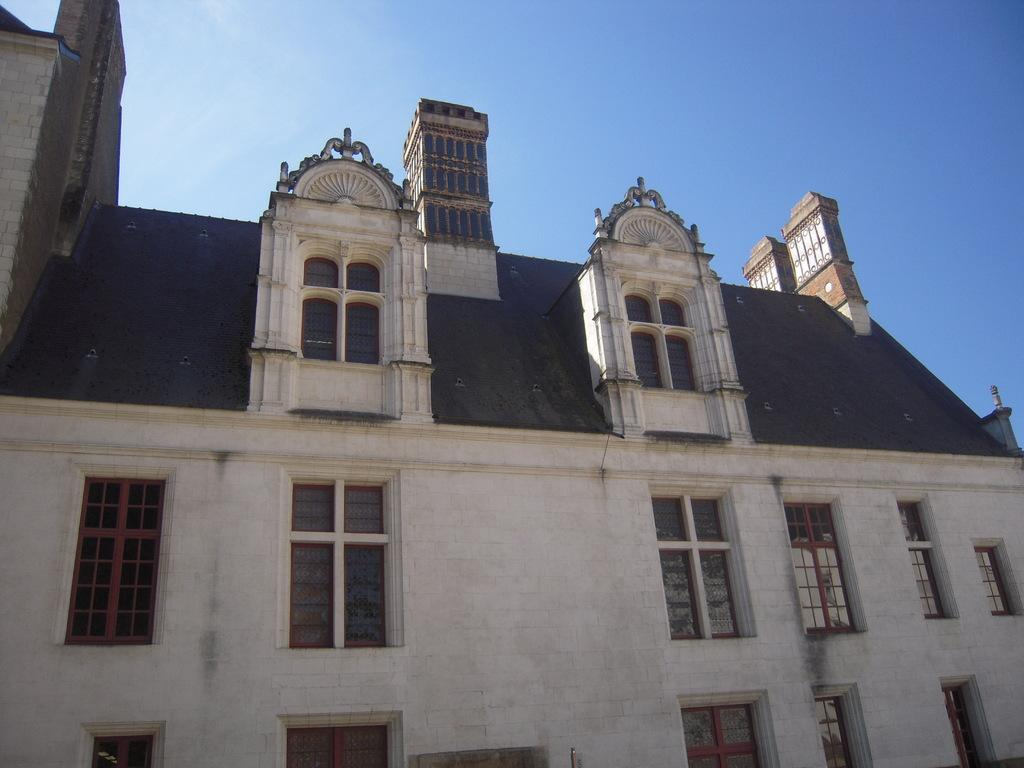What is the main subject of the picture? The main subject of the picture is a building. What specific features can be observed on the building? The building has windows. What is the condition of the sky in the picture? The sky is clear in the picture. What is the weather like in the image? It is sunny in the image. Can you see any pears growing near the seashore in the image? There is no seashore or pear trees present in the image; it features a building with clear skies and sunny weather. 